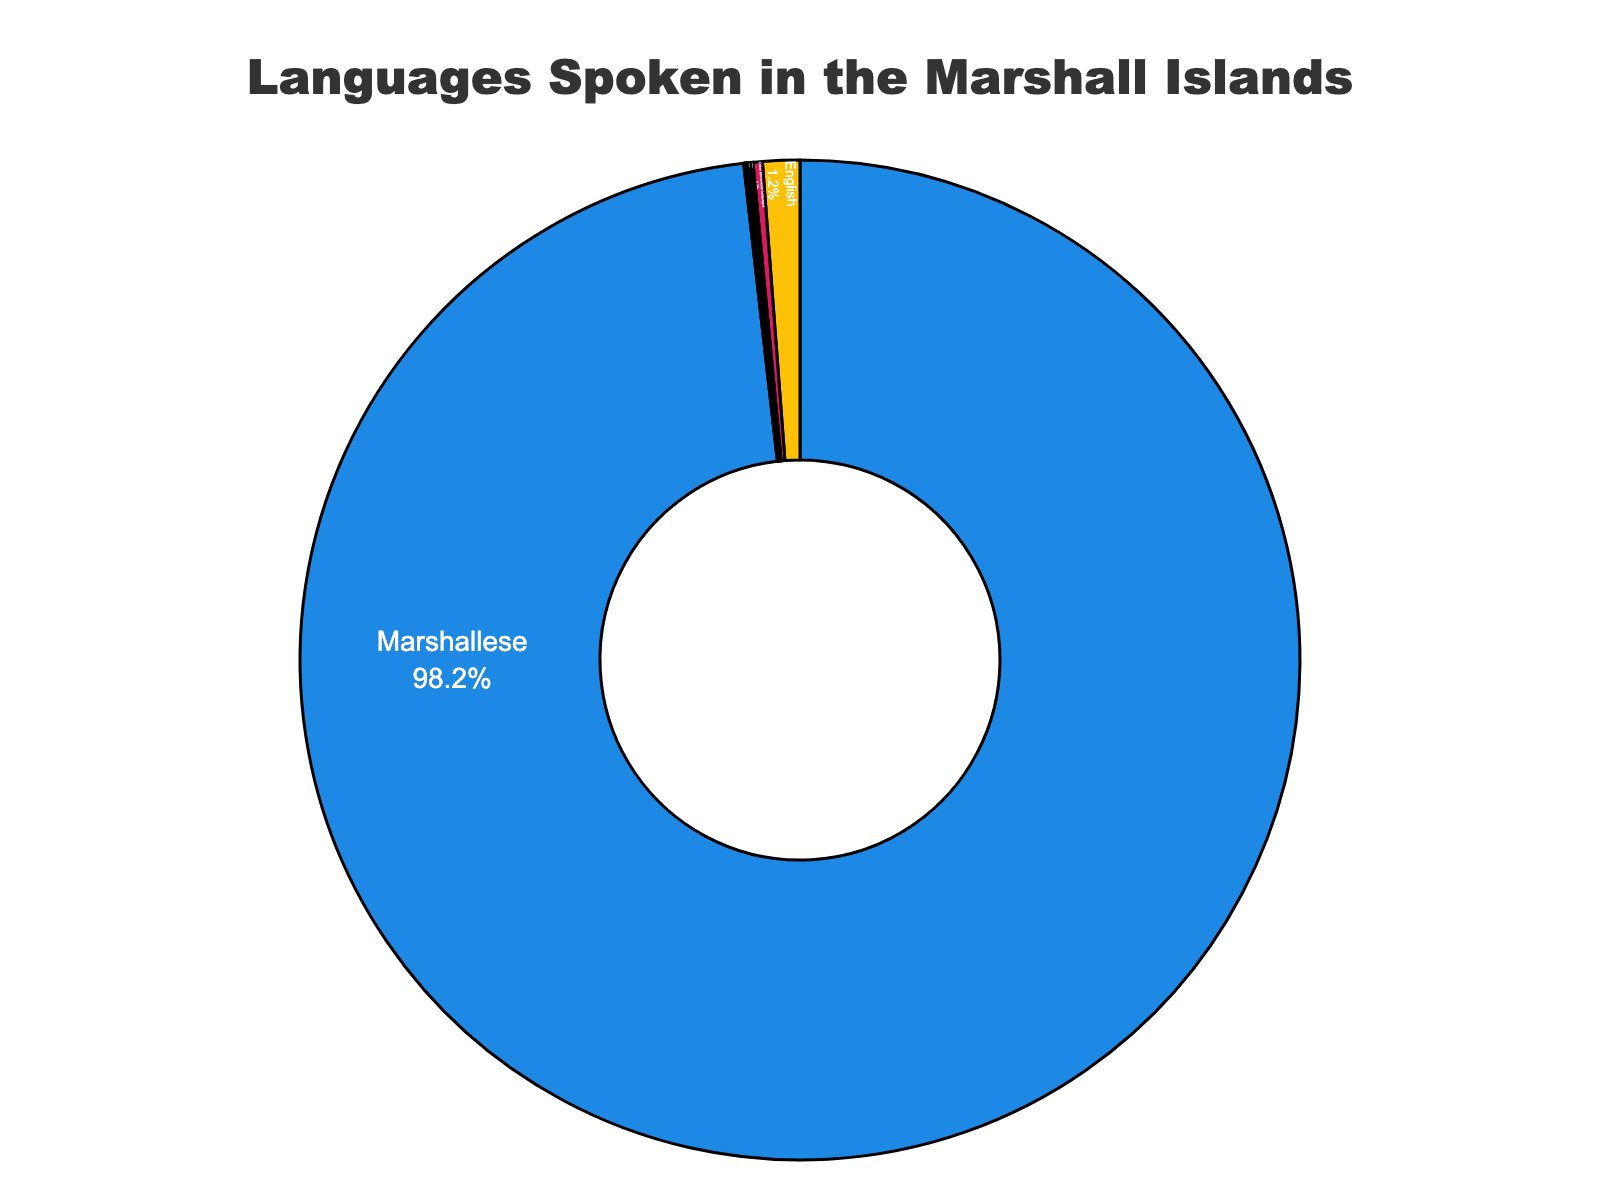What percentage of people speak Marshallese? The figure shows that Marshallese has a percentage of 98.2% directly labeled inside the chart.
Answer: 98.2% Which language is spoken by less than 0.1% of the people? The figure indicates that Korean, with a percentage of 0.03%, is spoken by less than 0.1% of the people.
Answer: Korean How much more popular is English compared to Chinese? The percentage for English is 1.2%, and for Chinese, it is 0.1%. Subtracting these values gives the difference. 1.2% - 0.1% = 1.1%
Answer: 1.1% Which languages are spoken by exactly 0.1% of the people? By examining the labels inside the pie chart, we see that both Japanese and Chinese are spoken by exactly 0.1% of the people.
Answer: Japanese, Chinese Summing up the percentages of all languages other than Marshallese, what is the result? Sum of English (1.2%), Other Micronesian languages (0.3%), Japanese (0.1%), Chinese (0.1%), Filipino (0.05%), Korean (0.03%), and Other (0.02%). So, 1.2 + 0.3 + 0.1 + 0.1 + 0.05 + 0.03 + 0.02 = 1.8%
Answer: 1.8% What is the color of the section representing English? English is represented by a golden yellow color in the pie chart.
Answer: golden yellow How does the percentage of Other Micronesian languages compare to that of Filipino? Other Micronesian languages have a percentage of 0.3%, and Filipino has a percentage of 0.05%. 0.3% is greater than 0.05%.
Answer: Other Micronesian languages > Filipino Which language has the smallest percentage of speakers? The figure indicates that the language labeled "Other" has the smallest percentage of speakers at 0.02%.
Answer: Other 